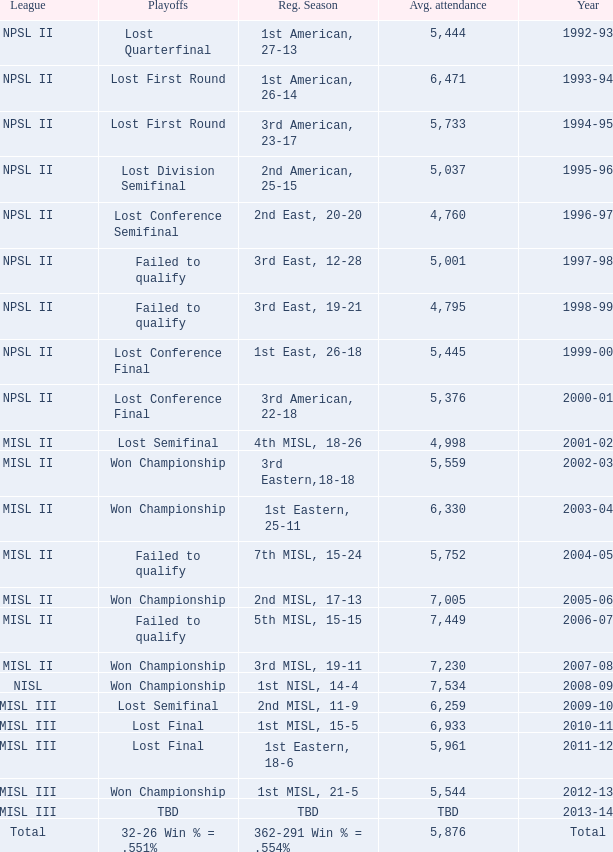When was the year that had an average attendance of 5,445? 1999-00. 